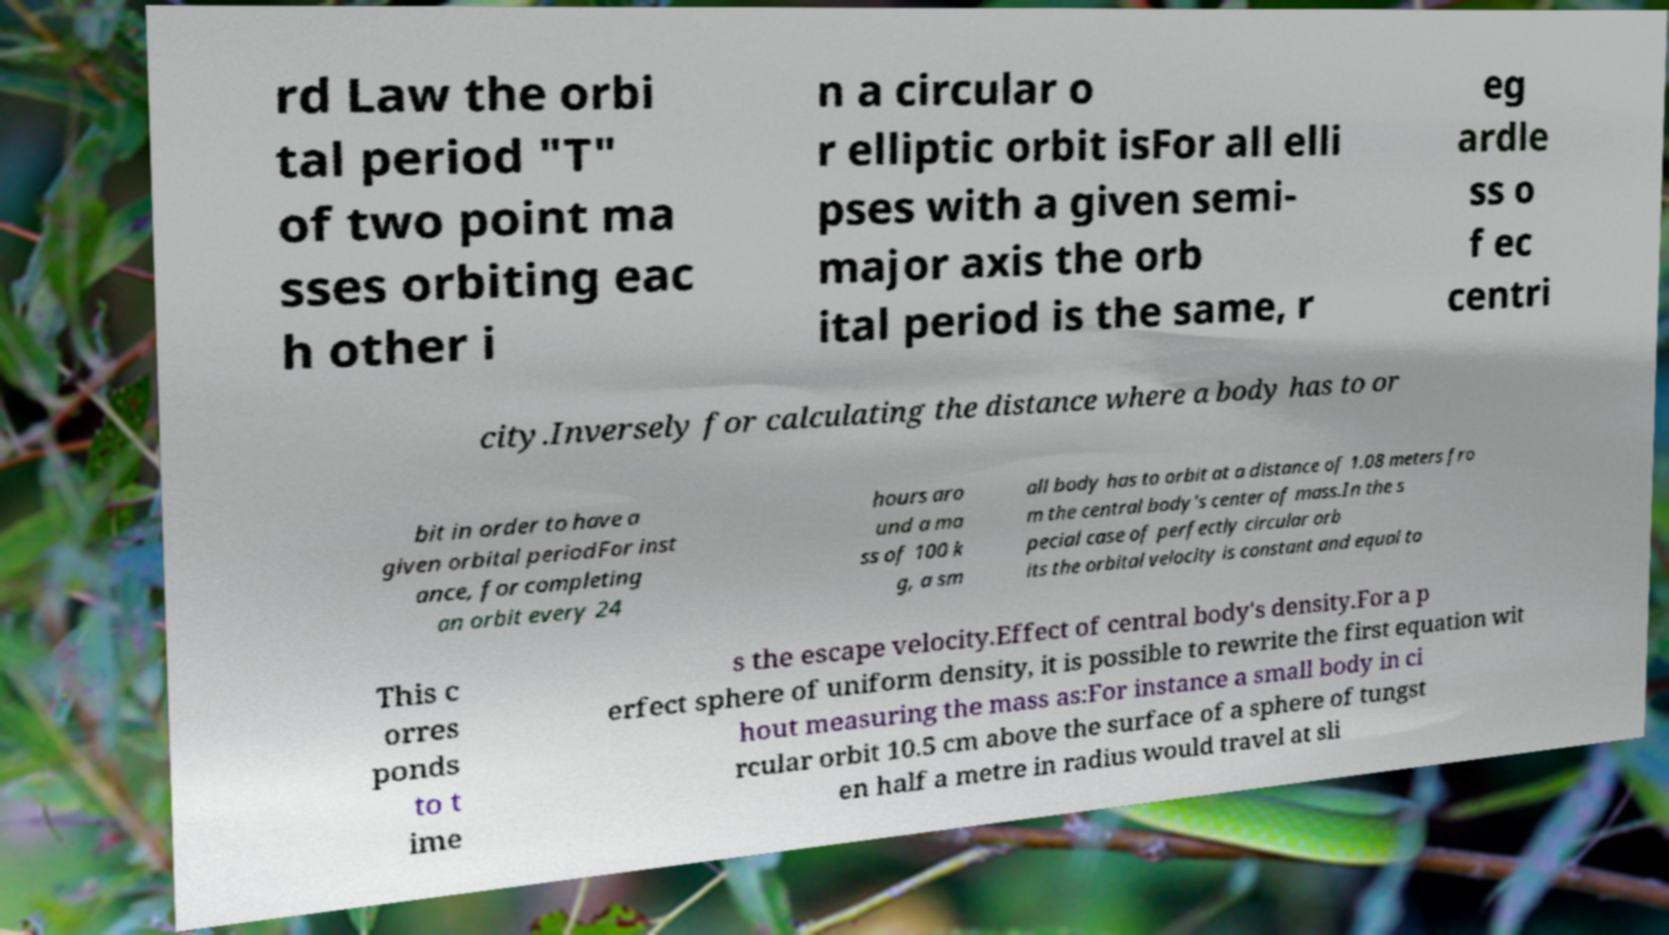For documentation purposes, I need the text within this image transcribed. Could you provide that? rd Law the orbi tal period "T" of two point ma sses orbiting eac h other i n a circular o r elliptic orbit isFor all elli pses with a given semi- major axis the orb ital period is the same, r eg ardle ss o f ec centri city.Inversely for calculating the distance where a body has to or bit in order to have a given orbital periodFor inst ance, for completing an orbit every 24 hours aro und a ma ss of 100 k g, a sm all body has to orbit at a distance of 1.08 meters fro m the central body's center of mass.In the s pecial case of perfectly circular orb its the orbital velocity is constant and equal to This c orres ponds to t ime s the escape velocity.Effect of central body's density.For a p erfect sphere of uniform density, it is possible to rewrite the first equation wit hout measuring the mass as:For instance a small body in ci rcular orbit 10.5 cm above the surface of a sphere of tungst en half a metre in radius would travel at sli 